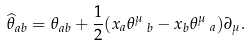Convert formula to latex. <formula><loc_0><loc_0><loc_500><loc_500>\widehat { \theta } _ { a b } = \theta _ { a b } + \frac { 1 } { 2 } ( x _ { a } \theta ^ { \mu } \, _ { b } - x _ { b } \theta ^ { \mu } \, _ { a } ) \partial _ { \mu } .</formula> 